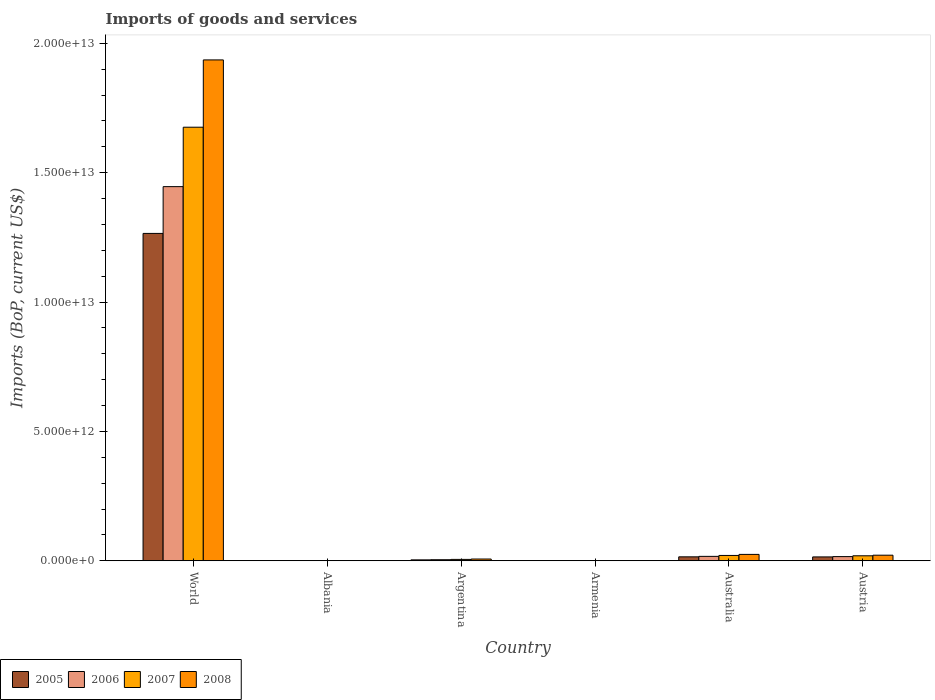How many different coloured bars are there?
Your answer should be very brief. 4. Are the number of bars on each tick of the X-axis equal?
Keep it short and to the point. Yes. How many bars are there on the 6th tick from the left?
Offer a very short reply. 4. What is the label of the 2nd group of bars from the left?
Keep it short and to the point. Albania. In how many cases, is the number of bars for a given country not equal to the number of legend labels?
Provide a short and direct response. 0. What is the amount spent on imports in 2007 in Austria?
Make the answer very short. 1.93e+11. Across all countries, what is the maximum amount spent on imports in 2008?
Make the answer very short. 1.94e+13. Across all countries, what is the minimum amount spent on imports in 2007?
Give a very brief answer. 3.88e+09. In which country was the amount spent on imports in 2006 maximum?
Your answer should be compact. World. In which country was the amount spent on imports in 2008 minimum?
Provide a succinct answer. Armenia. What is the total amount spent on imports in 2007 in the graph?
Offer a terse response. 1.72e+13. What is the difference between the amount spent on imports in 2007 in Austria and that in World?
Give a very brief answer. -1.66e+13. What is the difference between the amount spent on imports in 2008 in World and the amount spent on imports in 2006 in Argentina?
Ensure brevity in your answer.  1.93e+13. What is the average amount spent on imports in 2008 per country?
Offer a terse response. 3.32e+12. What is the difference between the amount spent on imports of/in 2005 and amount spent on imports of/in 2007 in World?
Your answer should be very brief. -4.10e+12. What is the ratio of the amount spent on imports in 2007 in Albania to that in Austria?
Make the answer very short. 0.03. Is the amount spent on imports in 2005 in Albania less than that in Armenia?
Make the answer very short. No. Is the difference between the amount spent on imports in 2005 in Albania and World greater than the difference between the amount spent on imports in 2007 in Albania and World?
Provide a short and direct response. Yes. What is the difference between the highest and the second highest amount spent on imports in 2007?
Your answer should be very brief. 1.66e+13. What is the difference between the highest and the lowest amount spent on imports in 2007?
Your answer should be compact. 1.68e+13. Is the sum of the amount spent on imports in 2005 in Albania and Austria greater than the maximum amount spent on imports in 2008 across all countries?
Your answer should be compact. No. Is it the case that in every country, the sum of the amount spent on imports in 2008 and amount spent on imports in 2006 is greater than the sum of amount spent on imports in 2007 and amount spent on imports in 2005?
Provide a succinct answer. No. What does the 3rd bar from the left in Australia represents?
Provide a short and direct response. 2007. Are all the bars in the graph horizontal?
Offer a very short reply. No. What is the difference between two consecutive major ticks on the Y-axis?
Your answer should be very brief. 5.00e+12. Are the values on the major ticks of Y-axis written in scientific E-notation?
Offer a terse response. Yes. Does the graph contain any zero values?
Keep it short and to the point. No. How are the legend labels stacked?
Provide a short and direct response. Horizontal. What is the title of the graph?
Ensure brevity in your answer.  Imports of goods and services. Does "2015" appear as one of the legend labels in the graph?
Your answer should be very brief. No. What is the label or title of the Y-axis?
Provide a short and direct response. Imports (BoP, current US$). What is the Imports (BoP, current US$) of 2005 in World?
Your answer should be very brief. 1.27e+13. What is the Imports (BoP, current US$) of 2006 in World?
Provide a succinct answer. 1.45e+13. What is the Imports (BoP, current US$) in 2007 in World?
Make the answer very short. 1.68e+13. What is the Imports (BoP, current US$) of 2008 in World?
Your answer should be very brief. 1.94e+13. What is the Imports (BoP, current US$) in 2005 in Albania?
Offer a very short reply. 3.50e+09. What is the Imports (BoP, current US$) in 2006 in Albania?
Keep it short and to the point. 4.07e+09. What is the Imports (BoP, current US$) in 2007 in Albania?
Make the answer very short. 5.34e+09. What is the Imports (BoP, current US$) of 2008 in Albania?
Your answer should be compact. 6.73e+09. What is the Imports (BoP, current US$) of 2005 in Argentina?
Keep it short and to the point. 3.48e+1. What is the Imports (BoP, current US$) of 2006 in Argentina?
Keep it short and to the point. 4.10e+1. What is the Imports (BoP, current US$) in 2007 in Argentina?
Your response must be concise. 5.32e+1. What is the Imports (BoP, current US$) in 2008 in Argentina?
Make the answer very short. 6.79e+1. What is the Imports (BoP, current US$) in 2005 in Armenia?
Give a very brief answer. 2.24e+09. What is the Imports (BoP, current US$) of 2006 in Armenia?
Offer a very short reply. 2.68e+09. What is the Imports (BoP, current US$) of 2007 in Armenia?
Your answer should be very brief. 3.88e+09. What is the Imports (BoP, current US$) of 2008 in Armenia?
Make the answer very short. 5.07e+09. What is the Imports (BoP, current US$) in 2005 in Australia?
Your response must be concise. 1.52e+11. What is the Imports (BoP, current US$) in 2006 in Australia?
Provide a short and direct response. 1.70e+11. What is the Imports (BoP, current US$) in 2007 in Australia?
Make the answer very short. 2.06e+11. What is the Imports (BoP, current US$) of 2008 in Australia?
Ensure brevity in your answer.  2.46e+11. What is the Imports (BoP, current US$) in 2005 in Austria?
Ensure brevity in your answer.  1.49e+11. What is the Imports (BoP, current US$) in 2006 in Austria?
Your answer should be very brief. 1.61e+11. What is the Imports (BoP, current US$) in 2007 in Austria?
Make the answer very short. 1.93e+11. What is the Imports (BoP, current US$) of 2008 in Austria?
Your response must be concise. 2.16e+11. Across all countries, what is the maximum Imports (BoP, current US$) in 2005?
Provide a short and direct response. 1.27e+13. Across all countries, what is the maximum Imports (BoP, current US$) of 2006?
Provide a short and direct response. 1.45e+13. Across all countries, what is the maximum Imports (BoP, current US$) in 2007?
Your answer should be very brief. 1.68e+13. Across all countries, what is the maximum Imports (BoP, current US$) in 2008?
Make the answer very short. 1.94e+13. Across all countries, what is the minimum Imports (BoP, current US$) in 2005?
Keep it short and to the point. 2.24e+09. Across all countries, what is the minimum Imports (BoP, current US$) in 2006?
Provide a short and direct response. 2.68e+09. Across all countries, what is the minimum Imports (BoP, current US$) in 2007?
Make the answer very short. 3.88e+09. Across all countries, what is the minimum Imports (BoP, current US$) of 2008?
Offer a very short reply. 5.07e+09. What is the total Imports (BoP, current US$) in 2005 in the graph?
Offer a terse response. 1.30e+13. What is the total Imports (BoP, current US$) in 2006 in the graph?
Your response must be concise. 1.48e+13. What is the total Imports (BoP, current US$) in 2007 in the graph?
Offer a very short reply. 1.72e+13. What is the total Imports (BoP, current US$) of 2008 in the graph?
Make the answer very short. 1.99e+13. What is the difference between the Imports (BoP, current US$) in 2005 in World and that in Albania?
Ensure brevity in your answer.  1.26e+13. What is the difference between the Imports (BoP, current US$) of 2006 in World and that in Albania?
Your answer should be very brief. 1.45e+13. What is the difference between the Imports (BoP, current US$) of 2007 in World and that in Albania?
Your answer should be compact. 1.68e+13. What is the difference between the Imports (BoP, current US$) of 2008 in World and that in Albania?
Your answer should be very brief. 1.93e+13. What is the difference between the Imports (BoP, current US$) in 2005 in World and that in Argentina?
Your answer should be compact. 1.26e+13. What is the difference between the Imports (BoP, current US$) in 2006 in World and that in Argentina?
Your answer should be compact. 1.44e+13. What is the difference between the Imports (BoP, current US$) of 2007 in World and that in Argentina?
Offer a very short reply. 1.67e+13. What is the difference between the Imports (BoP, current US$) of 2008 in World and that in Argentina?
Give a very brief answer. 1.93e+13. What is the difference between the Imports (BoP, current US$) in 2005 in World and that in Armenia?
Offer a terse response. 1.26e+13. What is the difference between the Imports (BoP, current US$) in 2006 in World and that in Armenia?
Your answer should be compact. 1.45e+13. What is the difference between the Imports (BoP, current US$) in 2007 in World and that in Armenia?
Your answer should be very brief. 1.68e+13. What is the difference between the Imports (BoP, current US$) in 2008 in World and that in Armenia?
Give a very brief answer. 1.94e+13. What is the difference between the Imports (BoP, current US$) in 2005 in World and that in Australia?
Your response must be concise. 1.25e+13. What is the difference between the Imports (BoP, current US$) of 2006 in World and that in Australia?
Your response must be concise. 1.43e+13. What is the difference between the Imports (BoP, current US$) in 2007 in World and that in Australia?
Your answer should be very brief. 1.65e+13. What is the difference between the Imports (BoP, current US$) in 2008 in World and that in Australia?
Provide a succinct answer. 1.91e+13. What is the difference between the Imports (BoP, current US$) of 2005 in World and that in Austria?
Provide a succinct answer. 1.25e+13. What is the difference between the Imports (BoP, current US$) of 2006 in World and that in Austria?
Provide a succinct answer. 1.43e+13. What is the difference between the Imports (BoP, current US$) of 2007 in World and that in Austria?
Your response must be concise. 1.66e+13. What is the difference between the Imports (BoP, current US$) of 2008 in World and that in Austria?
Your answer should be very brief. 1.91e+13. What is the difference between the Imports (BoP, current US$) in 2005 in Albania and that in Argentina?
Give a very brief answer. -3.13e+1. What is the difference between the Imports (BoP, current US$) of 2006 in Albania and that in Argentina?
Provide a short and direct response. -3.69e+1. What is the difference between the Imports (BoP, current US$) in 2007 in Albania and that in Argentina?
Ensure brevity in your answer.  -4.79e+1. What is the difference between the Imports (BoP, current US$) in 2008 in Albania and that in Argentina?
Offer a very short reply. -6.11e+1. What is the difference between the Imports (BoP, current US$) in 2005 in Albania and that in Armenia?
Give a very brief answer. 1.26e+09. What is the difference between the Imports (BoP, current US$) of 2006 in Albania and that in Armenia?
Provide a succinct answer. 1.39e+09. What is the difference between the Imports (BoP, current US$) in 2007 in Albania and that in Armenia?
Ensure brevity in your answer.  1.47e+09. What is the difference between the Imports (BoP, current US$) in 2008 in Albania and that in Armenia?
Ensure brevity in your answer.  1.66e+09. What is the difference between the Imports (BoP, current US$) of 2005 in Albania and that in Australia?
Offer a very short reply. -1.49e+11. What is the difference between the Imports (BoP, current US$) in 2006 in Albania and that in Australia?
Offer a very short reply. -1.66e+11. What is the difference between the Imports (BoP, current US$) of 2007 in Albania and that in Australia?
Your response must be concise. -2.00e+11. What is the difference between the Imports (BoP, current US$) of 2008 in Albania and that in Australia?
Give a very brief answer. -2.40e+11. What is the difference between the Imports (BoP, current US$) in 2005 in Albania and that in Austria?
Your answer should be compact. -1.45e+11. What is the difference between the Imports (BoP, current US$) in 2006 in Albania and that in Austria?
Provide a succinct answer. -1.57e+11. What is the difference between the Imports (BoP, current US$) in 2007 in Albania and that in Austria?
Offer a very short reply. -1.87e+11. What is the difference between the Imports (BoP, current US$) in 2008 in Albania and that in Austria?
Make the answer very short. -2.09e+11. What is the difference between the Imports (BoP, current US$) in 2005 in Argentina and that in Armenia?
Your answer should be compact. 3.26e+1. What is the difference between the Imports (BoP, current US$) of 2006 in Argentina and that in Armenia?
Keep it short and to the point. 3.83e+1. What is the difference between the Imports (BoP, current US$) in 2007 in Argentina and that in Armenia?
Your answer should be very brief. 4.94e+1. What is the difference between the Imports (BoP, current US$) of 2008 in Argentina and that in Armenia?
Keep it short and to the point. 6.28e+1. What is the difference between the Imports (BoP, current US$) in 2005 in Argentina and that in Australia?
Provide a succinct answer. -1.17e+11. What is the difference between the Imports (BoP, current US$) of 2006 in Argentina and that in Australia?
Your answer should be very brief. -1.29e+11. What is the difference between the Imports (BoP, current US$) of 2007 in Argentina and that in Australia?
Give a very brief answer. -1.53e+11. What is the difference between the Imports (BoP, current US$) of 2008 in Argentina and that in Australia?
Make the answer very short. -1.79e+11. What is the difference between the Imports (BoP, current US$) in 2005 in Argentina and that in Austria?
Ensure brevity in your answer.  -1.14e+11. What is the difference between the Imports (BoP, current US$) in 2006 in Argentina and that in Austria?
Your answer should be very brief. -1.20e+11. What is the difference between the Imports (BoP, current US$) in 2007 in Argentina and that in Austria?
Ensure brevity in your answer.  -1.39e+11. What is the difference between the Imports (BoP, current US$) of 2008 in Argentina and that in Austria?
Give a very brief answer. -1.48e+11. What is the difference between the Imports (BoP, current US$) of 2005 in Armenia and that in Australia?
Your answer should be very brief. -1.50e+11. What is the difference between the Imports (BoP, current US$) in 2006 in Armenia and that in Australia?
Provide a succinct answer. -1.67e+11. What is the difference between the Imports (BoP, current US$) of 2007 in Armenia and that in Australia?
Your answer should be compact. -2.02e+11. What is the difference between the Imports (BoP, current US$) of 2008 in Armenia and that in Australia?
Give a very brief answer. -2.41e+11. What is the difference between the Imports (BoP, current US$) of 2005 in Armenia and that in Austria?
Keep it short and to the point. -1.47e+11. What is the difference between the Imports (BoP, current US$) of 2006 in Armenia and that in Austria?
Offer a very short reply. -1.59e+11. What is the difference between the Imports (BoP, current US$) in 2007 in Armenia and that in Austria?
Make the answer very short. -1.89e+11. What is the difference between the Imports (BoP, current US$) of 2008 in Armenia and that in Austria?
Keep it short and to the point. -2.10e+11. What is the difference between the Imports (BoP, current US$) in 2005 in Australia and that in Austria?
Your response must be concise. 3.31e+09. What is the difference between the Imports (BoP, current US$) of 2006 in Australia and that in Austria?
Offer a very short reply. 8.59e+09. What is the difference between the Imports (BoP, current US$) in 2007 in Australia and that in Austria?
Provide a succinct answer. 1.33e+1. What is the difference between the Imports (BoP, current US$) in 2008 in Australia and that in Austria?
Give a very brief answer. 3.09e+1. What is the difference between the Imports (BoP, current US$) of 2005 in World and the Imports (BoP, current US$) of 2006 in Albania?
Ensure brevity in your answer.  1.26e+13. What is the difference between the Imports (BoP, current US$) of 2005 in World and the Imports (BoP, current US$) of 2007 in Albania?
Provide a succinct answer. 1.26e+13. What is the difference between the Imports (BoP, current US$) in 2005 in World and the Imports (BoP, current US$) in 2008 in Albania?
Offer a very short reply. 1.26e+13. What is the difference between the Imports (BoP, current US$) of 2006 in World and the Imports (BoP, current US$) of 2007 in Albania?
Ensure brevity in your answer.  1.45e+13. What is the difference between the Imports (BoP, current US$) in 2006 in World and the Imports (BoP, current US$) in 2008 in Albania?
Keep it short and to the point. 1.45e+13. What is the difference between the Imports (BoP, current US$) in 2007 in World and the Imports (BoP, current US$) in 2008 in Albania?
Your answer should be very brief. 1.67e+13. What is the difference between the Imports (BoP, current US$) of 2005 in World and the Imports (BoP, current US$) of 2006 in Argentina?
Keep it short and to the point. 1.26e+13. What is the difference between the Imports (BoP, current US$) of 2005 in World and the Imports (BoP, current US$) of 2007 in Argentina?
Give a very brief answer. 1.26e+13. What is the difference between the Imports (BoP, current US$) in 2005 in World and the Imports (BoP, current US$) in 2008 in Argentina?
Ensure brevity in your answer.  1.26e+13. What is the difference between the Imports (BoP, current US$) in 2006 in World and the Imports (BoP, current US$) in 2007 in Argentina?
Your answer should be compact. 1.44e+13. What is the difference between the Imports (BoP, current US$) of 2006 in World and the Imports (BoP, current US$) of 2008 in Argentina?
Your answer should be compact. 1.44e+13. What is the difference between the Imports (BoP, current US$) of 2007 in World and the Imports (BoP, current US$) of 2008 in Argentina?
Give a very brief answer. 1.67e+13. What is the difference between the Imports (BoP, current US$) in 2005 in World and the Imports (BoP, current US$) in 2006 in Armenia?
Provide a short and direct response. 1.26e+13. What is the difference between the Imports (BoP, current US$) in 2005 in World and the Imports (BoP, current US$) in 2007 in Armenia?
Offer a terse response. 1.26e+13. What is the difference between the Imports (BoP, current US$) of 2005 in World and the Imports (BoP, current US$) of 2008 in Armenia?
Your answer should be compact. 1.26e+13. What is the difference between the Imports (BoP, current US$) of 2006 in World and the Imports (BoP, current US$) of 2007 in Armenia?
Your response must be concise. 1.45e+13. What is the difference between the Imports (BoP, current US$) of 2006 in World and the Imports (BoP, current US$) of 2008 in Armenia?
Give a very brief answer. 1.45e+13. What is the difference between the Imports (BoP, current US$) in 2007 in World and the Imports (BoP, current US$) in 2008 in Armenia?
Provide a succinct answer. 1.68e+13. What is the difference between the Imports (BoP, current US$) of 2005 in World and the Imports (BoP, current US$) of 2006 in Australia?
Your answer should be compact. 1.25e+13. What is the difference between the Imports (BoP, current US$) of 2005 in World and the Imports (BoP, current US$) of 2007 in Australia?
Give a very brief answer. 1.24e+13. What is the difference between the Imports (BoP, current US$) in 2005 in World and the Imports (BoP, current US$) in 2008 in Australia?
Your answer should be compact. 1.24e+13. What is the difference between the Imports (BoP, current US$) in 2006 in World and the Imports (BoP, current US$) in 2007 in Australia?
Your answer should be very brief. 1.43e+13. What is the difference between the Imports (BoP, current US$) of 2006 in World and the Imports (BoP, current US$) of 2008 in Australia?
Your answer should be compact. 1.42e+13. What is the difference between the Imports (BoP, current US$) in 2007 in World and the Imports (BoP, current US$) in 2008 in Australia?
Your answer should be very brief. 1.65e+13. What is the difference between the Imports (BoP, current US$) in 2005 in World and the Imports (BoP, current US$) in 2006 in Austria?
Make the answer very short. 1.25e+13. What is the difference between the Imports (BoP, current US$) of 2005 in World and the Imports (BoP, current US$) of 2007 in Austria?
Give a very brief answer. 1.25e+13. What is the difference between the Imports (BoP, current US$) in 2005 in World and the Imports (BoP, current US$) in 2008 in Austria?
Give a very brief answer. 1.24e+13. What is the difference between the Imports (BoP, current US$) of 2006 in World and the Imports (BoP, current US$) of 2007 in Austria?
Keep it short and to the point. 1.43e+13. What is the difference between the Imports (BoP, current US$) in 2006 in World and the Imports (BoP, current US$) in 2008 in Austria?
Your answer should be compact. 1.42e+13. What is the difference between the Imports (BoP, current US$) of 2007 in World and the Imports (BoP, current US$) of 2008 in Austria?
Your answer should be compact. 1.65e+13. What is the difference between the Imports (BoP, current US$) of 2005 in Albania and the Imports (BoP, current US$) of 2006 in Argentina?
Provide a succinct answer. -3.75e+1. What is the difference between the Imports (BoP, current US$) in 2005 in Albania and the Imports (BoP, current US$) in 2007 in Argentina?
Make the answer very short. -4.97e+1. What is the difference between the Imports (BoP, current US$) in 2005 in Albania and the Imports (BoP, current US$) in 2008 in Argentina?
Ensure brevity in your answer.  -6.43e+1. What is the difference between the Imports (BoP, current US$) of 2006 in Albania and the Imports (BoP, current US$) of 2007 in Argentina?
Make the answer very short. -4.92e+1. What is the difference between the Imports (BoP, current US$) in 2006 in Albania and the Imports (BoP, current US$) in 2008 in Argentina?
Provide a short and direct response. -6.38e+1. What is the difference between the Imports (BoP, current US$) in 2007 in Albania and the Imports (BoP, current US$) in 2008 in Argentina?
Keep it short and to the point. -6.25e+1. What is the difference between the Imports (BoP, current US$) of 2005 in Albania and the Imports (BoP, current US$) of 2006 in Armenia?
Your response must be concise. 8.18e+08. What is the difference between the Imports (BoP, current US$) of 2005 in Albania and the Imports (BoP, current US$) of 2007 in Armenia?
Keep it short and to the point. -3.75e+08. What is the difference between the Imports (BoP, current US$) of 2005 in Albania and the Imports (BoP, current US$) of 2008 in Armenia?
Ensure brevity in your answer.  -1.57e+09. What is the difference between the Imports (BoP, current US$) of 2006 in Albania and the Imports (BoP, current US$) of 2007 in Armenia?
Provide a short and direct response. 1.98e+08. What is the difference between the Imports (BoP, current US$) of 2006 in Albania and the Imports (BoP, current US$) of 2008 in Armenia?
Offer a very short reply. -9.98e+08. What is the difference between the Imports (BoP, current US$) of 2007 in Albania and the Imports (BoP, current US$) of 2008 in Armenia?
Your answer should be compact. 2.73e+08. What is the difference between the Imports (BoP, current US$) in 2005 in Albania and the Imports (BoP, current US$) in 2006 in Australia?
Offer a terse response. -1.67e+11. What is the difference between the Imports (BoP, current US$) in 2005 in Albania and the Imports (BoP, current US$) in 2007 in Australia?
Make the answer very short. -2.02e+11. What is the difference between the Imports (BoP, current US$) of 2005 in Albania and the Imports (BoP, current US$) of 2008 in Australia?
Provide a succinct answer. -2.43e+11. What is the difference between the Imports (BoP, current US$) in 2006 in Albania and the Imports (BoP, current US$) in 2007 in Australia?
Your answer should be compact. -2.02e+11. What is the difference between the Imports (BoP, current US$) in 2006 in Albania and the Imports (BoP, current US$) in 2008 in Australia?
Your response must be concise. -2.42e+11. What is the difference between the Imports (BoP, current US$) in 2007 in Albania and the Imports (BoP, current US$) in 2008 in Australia?
Ensure brevity in your answer.  -2.41e+11. What is the difference between the Imports (BoP, current US$) of 2005 in Albania and the Imports (BoP, current US$) of 2006 in Austria?
Give a very brief answer. -1.58e+11. What is the difference between the Imports (BoP, current US$) in 2005 in Albania and the Imports (BoP, current US$) in 2007 in Austria?
Ensure brevity in your answer.  -1.89e+11. What is the difference between the Imports (BoP, current US$) in 2005 in Albania and the Imports (BoP, current US$) in 2008 in Austria?
Your answer should be very brief. -2.12e+11. What is the difference between the Imports (BoP, current US$) in 2006 in Albania and the Imports (BoP, current US$) in 2007 in Austria?
Provide a succinct answer. -1.88e+11. What is the difference between the Imports (BoP, current US$) of 2006 in Albania and the Imports (BoP, current US$) of 2008 in Austria?
Ensure brevity in your answer.  -2.11e+11. What is the difference between the Imports (BoP, current US$) in 2007 in Albania and the Imports (BoP, current US$) in 2008 in Austria?
Your answer should be very brief. -2.10e+11. What is the difference between the Imports (BoP, current US$) of 2005 in Argentina and the Imports (BoP, current US$) of 2006 in Armenia?
Keep it short and to the point. 3.21e+1. What is the difference between the Imports (BoP, current US$) in 2005 in Argentina and the Imports (BoP, current US$) in 2007 in Armenia?
Make the answer very short. 3.09e+1. What is the difference between the Imports (BoP, current US$) in 2005 in Argentina and the Imports (BoP, current US$) in 2008 in Armenia?
Provide a succinct answer. 2.97e+1. What is the difference between the Imports (BoP, current US$) of 2006 in Argentina and the Imports (BoP, current US$) of 2007 in Armenia?
Provide a succinct answer. 3.71e+1. What is the difference between the Imports (BoP, current US$) in 2006 in Argentina and the Imports (BoP, current US$) in 2008 in Armenia?
Give a very brief answer. 3.59e+1. What is the difference between the Imports (BoP, current US$) in 2007 in Argentina and the Imports (BoP, current US$) in 2008 in Armenia?
Your answer should be compact. 4.82e+1. What is the difference between the Imports (BoP, current US$) in 2005 in Argentina and the Imports (BoP, current US$) in 2006 in Australia?
Provide a short and direct response. -1.35e+11. What is the difference between the Imports (BoP, current US$) of 2005 in Argentina and the Imports (BoP, current US$) of 2007 in Australia?
Keep it short and to the point. -1.71e+11. What is the difference between the Imports (BoP, current US$) of 2005 in Argentina and the Imports (BoP, current US$) of 2008 in Australia?
Offer a terse response. -2.12e+11. What is the difference between the Imports (BoP, current US$) of 2006 in Argentina and the Imports (BoP, current US$) of 2007 in Australia?
Make the answer very short. -1.65e+11. What is the difference between the Imports (BoP, current US$) of 2006 in Argentina and the Imports (BoP, current US$) of 2008 in Australia?
Provide a succinct answer. -2.05e+11. What is the difference between the Imports (BoP, current US$) of 2007 in Argentina and the Imports (BoP, current US$) of 2008 in Australia?
Give a very brief answer. -1.93e+11. What is the difference between the Imports (BoP, current US$) of 2005 in Argentina and the Imports (BoP, current US$) of 2006 in Austria?
Offer a terse response. -1.27e+11. What is the difference between the Imports (BoP, current US$) of 2005 in Argentina and the Imports (BoP, current US$) of 2007 in Austria?
Your answer should be very brief. -1.58e+11. What is the difference between the Imports (BoP, current US$) in 2005 in Argentina and the Imports (BoP, current US$) in 2008 in Austria?
Offer a terse response. -1.81e+11. What is the difference between the Imports (BoP, current US$) in 2006 in Argentina and the Imports (BoP, current US$) in 2007 in Austria?
Keep it short and to the point. -1.52e+11. What is the difference between the Imports (BoP, current US$) of 2006 in Argentina and the Imports (BoP, current US$) of 2008 in Austria?
Provide a short and direct response. -1.75e+11. What is the difference between the Imports (BoP, current US$) of 2007 in Argentina and the Imports (BoP, current US$) of 2008 in Austria?
Provide a succinct answer. -1.62e+11. What is the difference between the Imports (BoP, current US$) of 2005 in Armenia and the Imports (BoP, current US$) of 2006 in Australia?
Provide a short and direct response. -1.68e+11. What is the difference between the Imports (BoP, current US$) in 2005 in Armenia and the Imports (BoP, current US$) in 2007 in Australia?
Ensure brevity in your answer.  -2.04e+11. What is the difference between the Imports (BoP, current US$) in 2005 in Armenia and the Imports (BoP, current US$) in 2008 in Australia?
Provide a succinct answer. -2.44e+11. What is the difference between the Imports (BoP, current US$) in 2006 in Armenia and the Imports (BoP, current US$) in 2007 in Australia?
Your response must be concise. -2.03e+11. What is the difference between the Imports (BoP, current US$) of 2006 in Armenia and the Imports (BoP, current US$) of 2008 in Australia?
Give a very brief answer. -2.44e+11. What is the difference between the Imports (BoP, current US$) in 2007 in Armenia and the Imports (BoP, current US$) in 2008 in Australia?
Offer a very short reply. -2.43e+11. What is the difference between the Imports (BoP, current US$) in 2005 in Armenia and the Imports (BoP, current US$) in 2006 in Austria?
Make the answer very short. -1.59e+11. What is the difference between the Imports (BoP, current US$) of 2005 in Armenia and the Imports (BoP, current US$) of 2007 in Austria?
Ensure brevity in your answer.  -1.90e+11. What is the difference between the Imports (BoP, current US$) of 2005 in Armenia and the Imports (BoP, current US$) of 2008 in Austria?
Offer a very short reply. -2.13e+11. What is the difference between the Imports (BoP, current US$) of 2006 in Armenia and the Imports (BoP, current US$) of 2007 in Austria?
Your answer should be compact. -1.90e+11. What is the difference between the Imports (BoP, current US$) in 2006 in Armenia and the Imports (BoP, current US$) in 2008 in Austria?
Ensure brevity in your answer.  -2.13e+11. What is the difference between the Imports (BoP, current US$) of 2007 in Armenia and the Imports (BoP, current US$) of 2008 in Austria?
Provide a short and direct response. -2.12e+11. What is the difference between the Imports (BoP, current US$) of 2005 in Australia and the Imports (BoP, current US$) of 2006 in Austria?
Your response must be concise. -9.18e+09. What is the difference between the Imports (BoP, current US$) in 2005 in Australia and the Imports (BoP, current US$) in 2007 in Austria?
Keep it short and to the point. -4.03e+1. What is the difference between the Imports (BoP, current US$) in 2005 in Australia and the Imports (BoP, current US$) in 2008 in Austria?
Your answer should be very brief. -6.32e+1. What is the difference between the Imports (BoP, current US$) in 2006 in Australia and the Imports (BoP, current US$) in 2007 in Austria?
Provide a succinct answer. -2.25e+1. What is the difference between the Imports (BoP, current US$) of 2006 in Australia and the Imports (BoP, current US$) of 2008 in Austria?
Offer a very short reply. -4.55e+1. What is the difference between the Imports (BoP, current US$) of 2007 in Australia and the Imports (BoP, current US$) of 2008 in Austria?
Your answer should be very brief. -9.68e+09. What is the average Imports (BoP, current US$) of 2005 per country?
Your answer should be very brief. 2.17e+12. What is the average Imports (BoP, current US$) in 2006 per country?
Offer a very short reply. 2.47e+12. What is the average Imports (BoP, current US$) of 2007 per country?
Your answer should be compact. 2.87e+12. What is the average Imports (BoP, current US$) in 2008 per country?
Your answer should be very brief. 3.32e+12. What is the difference between the Imports (BoP, current US$) in 2005 and Imports (BoP, current US$) in 2006 in World?
Make the answer very short. -1.81e+12. What is the difference between the Imports (BoP, current US$) of 2005 and Imports (BoP, current US$) of 2007 in World?
Give a very brief answer. -4.10e+12. What is the difference between the Imports (BoP, current US$) in 2005 and Imports (BoP, current US$) in 2008 in World?
Offer a very short reply. -6.71e+12. What is the difference between the Imports (BoP, current US$) of 2006 and Imports (BoP, current US$) of 2007 in World?
Ensure brevity in your answer.  -2.30e+12. What is the difference between the Imports (BoP, current US$) of 2006 and Imports (BoP, current US$) of 2008 in World?
Keep it short and to the point. -4.90e+12. What is the difference between the Imports (BoP, current US$) of 2007 and Imports (BoP, current US$) of 2008 in World?
Make the answer very short. -2.60e+12. What is the difference between the Imports (BoP, current US$) in 2005 and Imports (BoP, current US$) in 2006 in Albania?
Provide a short and direct response. -5.73e+08. What is the difference between the Imports (BoP, current US$) of 2005 and Imports (BoP, current US$) of 2007 in Albania?
Ensure brevity in your answer.  -1.84e+09. What is the difference between the Imports (BoP, current US$) of 2005 and Imports (BoP, current US$) of 2008 in Albania?
Your answer should be compact. -3.23e+09. What is the difference between the Imports (BoP, current US$) in 2006 and Imports (BoP, current US$) in 2007 in Albania?
Your answer should be compact. -1.27e+09. What is the difference between the Imports (BoP, current US$) in 2006 and Imports (BoP, current US$) in 2008 in Albania?
Your answer should be compact. -2.66e+09. What is the difference between the Imports (BoP, current US$) of 2007 and Imports (BoP, current US$) of 2008 in Albania?
Offer a very short reply. -1.39e+09. What is the difference between the Imports (BoP, current US$) of 2005 and Imports (BoP, current US$) of 2006 in Argentina?
Give a very brief answer. -6.18e+09. What is the difference between the Imports (BoP, current US$) in 2005 and Imports (BoP, current US$) in 2007 in Argentina?
Provide a succinct answer. -1.84e+1. What is the difference between the Imports (BoP, current US$) in 2005 and Imports (BoP, current US$) in 2008 in Argentina?
Provide a short and direct response. -3.31e+1. What is the difference between the Imports (BoP, current US$) of 2006 and Imports (BoP, current US$) of 2007 in Argentina?
Provide a succinct answer. -1.23e+1. What is the difference between the Imports (BoP, current US$) of 2006 and Imports (BoP, current US$) of 2008 in Argentina?
Provide a short and direct response. -2.69e+1. What is the difference between the Imports (BoP, current US$) in 2007 and Imports (BoP, current US$) in 2008 in Argentina?
Offer a very short reply. -1.46e+1. What is the difference between the Imports (BoP, current US$) in 2005 and Imports (BoP, current US$) in 2006 in Armenia?
Your answer should be very brief. -4.41e+08. What is the difference between the Imports (BoP, current US$) of 2005 and Imports (BoP, current US$) of 2007 in Armenia?
Your answer should be compact. -1.63e+09. What is the difference between the Imports (BoP, current US$) of 2005 and Imports (BoP, current US$) of 2008 in Armenia?
Your answer should be very brief. -2.83e+09. What is the difference between the Imports (BoP, current US$) of 2006 and Imports (BoP, current US$) of 2007 in Armenia?
Make the answer very short. -1.19e+09. What is the difference between the Imports (BoP, current US$) in 2006 and Imports (BoP, current US$) in 2008 in Armenia?
Offer a very short reply. -2.39e+09. What is the difference between the Imports (BoP, current US$) in 2007 and Imports (BoP, current US$) in 2008 in Armenia?
Your answer should be very brief. -1.20e+09. What is the difference between the Imports (BoP, current US$) of 2005 and Imports (BoP, current US$) of 2006 in Australia?
Provide a short and direct response. -1.78e+1. What is the difference between the Imports (BoP, current US$) of 2005 and Imports (BoP, current US$) of 2007 in Australia?
Make the answer very short. -5.36e+1. What is the difference between the Imports (BoP, current US$) of 2005 and Imports (BoP, current US$) of 2008 in Australia?
Offer a terse response. -9.42e+1. What is the difference between the Imports (BoP, current US$) in 2006 and Imports (BoP, current US$) in 2007 in Australia?
Keep it short and to the point. -3.58e+1. What is the difference between the Imports (BoP, current US$) of 2006 and Imports (BoP, current US$) of 2008 in Australia?
Provide a succinct answer. -7.64e+1. What is the difference between the Imports (BoP, current US$) in 2007 and Imports (BoP, current US$) in 2008 in Australia?
Your answer should be compact. -4.06e+1. What is the difference between the Imports (BoP, current US$) in 2005 and Imports (BoP, current US$) in 2006 in Austria?
Provide a short and direct response. -1.25e+1. What is the difference between the Imports (BoP, current US$) of 2005 and Imports (BoP, current US$) of 2007 in Austria?
Provide a short and direct response. -4.36e+1. What is the difference between the Imports (BoP, current US$) in 2005 and Imports (BoP, current US$) in 2008 in Austria?
Offer a terse response. -6.66e+1. What is the difference between the Imports (BoP, current US$) of 2006 and Imports (BoP, current US$) of 2007 in Austria?
Give a very brief answer. -3.11e+1. What is the difference between the Imports (BoP, current US$) of 2006 and Imports (BoP, current US$) of 2008 in Austria?
Make the answer very short. -5.41e+1. What is the difference between the Imports (BoP, current US$) of 2007 and Imports (BoP, current US$) of 2008 in Austria?
Make the answer very short. -2.30e+1. What is the ratio of the Imports (BoP, current US$) in 2005 in World to that in Albania?
Keep it short and to the point. 3614.24. What is the ratio of the Imports (BoP, current US$) of 2006 in World to that in Albania?
Give a very brief answer. 3549.9. What is the ratio of the Imports (BoP, current US$) in 2007 in World to that in Albania?
Give a very brief answer. 3135.35. What is the ratio of the Imports (BoP, current US$) of 2008 in World to that in Albania?
Provide a succinct answer. 2875.75. What is the ratio of the Imports (BoP, current US$) of 2005 in World to that in Argentina?
Your answer should be compact. 363.57. What is the ratio of the Imports (BoP, current US$) of 2006 in World to that in Argentina?
Give a very brief answer. 352.89. What is the ratio of the Imports (BoP, current US$) of 2007 in World to that in Argentina?
Your answer should be very brief. 314.8. What is the ratio of the Imports (BoP, current US$) in 2008 in World to that in Argentina?
Give a very brief answer. 285.28. What is the ratio of the Imports (BoP, current US$) in 2005 in World to that in Armenia?
Keep it short and to the point. 5644.18. What is the ratio of the Imports (BoP, current US$) in 2006 in World to that in Armenia?
Provide a succinct answer. 5391.26. What is the ratio of the Imports (BoP, current US$) of 2007 in World to that in Armenia?
Your response must be concise. 4323.73. What is the ratio of the Imports (BoP, current US$) in 2008 in World to that in Armenia?
Keep it short and to the point. 3816.97. What is the ratio of the Imports (BoP, current US$) in 2005 in World to that in Australia?
Make the answer very short. 83.09. What is the ratio of the Imports (BoP, current US$) of 2006 in World to that in Australia?
Provide a short and direct response. 85.04. What is the ratio of the Imports (BoP, current US$) in 2007 in World to that in Australia?
Offer a terse response. 81.41. What is the ratio of the Imports (BoP, current US$) in 2008 in World to that in Australia?
Keep it short and to the point. 78.55. What is the ratio of the Imports (BoP, current US$) in 2005 in World to that in Austria?
Your answer should be very brief. 84.94. What is the ratio of the Imports (BoP, current US$) of 2006 in World to that in Austria?
Keep it short and to the point. 89.57. What is the ratio of the Imports (BoP, current US$) in 2007 in World to that in Austria?
Ensure brevity in your answer.  87.02. What is the ratio of the Imports (BoP, current US$) in 2008 in World to that in Austria?
Give a very brief answer. 89.82. What is the ratio of the Imports (BoP, current US$) of 2005 in Albania to that in Argentina?
Offer a terse response. 0.1. What is the ratio of the Imports (BoP, current US$) in 2006 in Albania to that in Argentina?
Offer a very short reply. 0.1. What is the ratio of the Imports (BoP, current US$) in 2007 in Albania to that in Argentina?
Your answer should be very brief. 0.1. What is the ratio of the Imports (BoP, current US$) in 2008 in Albania to that in Argentina?
Provide a succinct answer. 0.1. What is the ratio of the Imports (BoP, current US$) in 2005 in Albania to that in Armenia?
Give a very brief answer. 1.56. What is the ratio of the Imports (BoP, current US$) of 2006 in Albania to that in Armenia?
Provide a succinct answer. 1.52. What is the ratio of the Imports (BoP, current US$) in 2007 in Albania to that in Armenia?
Offer a very short reply. 1.38. What is the ratio of the Imports (BoP, current US$) of 2008 in Albania to that in Armenia?
Offer a very short reply. 1.33. What is the ratio of the Imports (BoP, current US$) of 2005 in Albania to that in Australia?
Your answer should be compact. 0.02. What is the ratio of the Imports (BoP, current US$) in 2006 in Albania to that in Australia?
Give a very brief answer. 0.02. What is the ratio of the Imports (BoP, current US$) in 2007 in Albania to that in Australia?
Provide a short and direct response. 0.03. What is the ratio of the Imports (BoP, current US$) of 2008 in Albania to that in Australia?
Provide a succinct answer. 0.03. What is the ratio of the Imports (BoP, current US$) in 2005 in Albania to that in Austria?
Make the answer very short. 0.02. What is the ratio of the Imports (BoP, current US$) in 2006 in Albania to that in Austria?
Your answer should be compact. 0.03. What is the ratio of the Imports (BoP, current US$) in 2007 in Albania to that in Austria?
Offer a very short reply. 0.03. What is the ratio of the Imports (BoP, current US$) in 2008 in Albania to that in Austria?
Make the answer very short. 0.03. What is the ratio of the Imports (BoP, current US$) in 2005 in Argentina to that in Armenia?
Your response must be concise. 15.52. What is the ratio of the Imports (BoP, current US$) in 2006 in Argentina to that in Armenia?
Offer a very short reply. 15.28. What is the ratio of the Imports (BoP, current US$) in 2007 in Argentina to that in Armenia?
Give a very brief answer. 13.73. What is the ratio of the Imports (BoP, current US$) of 2008 in Argentina to that in Armenia?
Your response must be concise. 13.38. What is the ratio of the Imports (BoP, current US$) of 2005 in Argentina to that in Australia?
Offer a very short reply. 0.23. What is the ratio of the Imports (BoP, current US$) in 2006 in Argentina to that in Australia?
Provide a short and direct response. 0.24. What is the ratio of the Imports (BoP, current US$) of 2007 in Argentina to that in Australia?
Offer a very short reply. 0.26. What is the ratio of the Imports (BoP, current US$) of 2008 in Argentina to that in Australia?
Your response must be concise. 0.28. What is the ratio of the Imports (BoP, current US$) in 2005 in Argentina to that in Austria?
Your response must be concise. 0.23. What is the ratio of the Imports (BoP, current US$) of 2006 in Argentina to that in Austria?
Provide a succinct answer. 0.25. What is the ratio of the Imports (BoP, current US$) in 2007 in Argentina to that in Austria?
Offer a terse response. 0.28. What is the ratio of the Imports (BoP, current US$) in 2008 in Argentina to that in Austria?
Keep it short and to the point. 0.31. What is the ratio of the Imports (BoP, current US$) in 2005 in Armenia to that in Australia?
Ensure brevity in your answer.  0.01. What is the ratio of the Imports (BoP, current US$) in 2006 in Armenia to that in Australia?
Offer a very short reply. 0.02. What is the ratio of the Imports (BoP, current US$) of 2007 in Armenia to that in Australia?
Your response must be concise. 0.02. What is the ratio of the Imports (BoP, current US$) of 2008 in Armenia to that in Australia?
Offer a terse response. 0.02. What is the ratio of the Imports (BoP, current US$) in 2005 in Armenia to that in Austria?
Offer a very short reply. 0.01. What is the ratio of the Imports (BoP, current US$) in 2006 in Armenia to that in Austria?
Your response must be concise. 0.02. What is the ratio of the Imports (BoP, current US$) of 2007 in Armenia to that in Austria?
Your answer should be compact. 0.02. What is the ratio of the Imports (BoP, current US$) of 2008 in Armenia to that in Austria?
Offer a very short reply. 0.02. What is the ratio of the Imports (BoP, current US$) of 2005 in Australia to that in Austria?
Provide a short and direct response. 1.02. What is the ratio of the Imports (BoP, current US$) in 2006 in Australia to that in Austria?
Offer a very short reply. 1.05. What is the ratio of the Imports (BoP, current US$) of 2007 in Australia to that in Austria?
Offer a very short reply. 1.07. What is the ratio of the Imports (BoP, current US$) in 2008 in Australia to that in Austria?
Give a very brief answer. 1.14. What is the difference between the highest and the second highest Imports (BoP, current US$) of 2005?
Give a very brief answer. 1.25e+13. What is the difference between the highest and the second highest Imports (BoP, current US$) of 2006?
Keep it short and to the point. 1.43e+13. What is the difference between the highest and the second highest Imports (BoP, current US$) of 2007?
Your answer should be very brief. 1.65e+13. What is the difference between the highest and the second highest Imports (BoP, current US$) in 2008?
Your answer should be compact. 1.91e+13. What is the difference between the highest and the lowest Imports (BoP, current US$) in 2005?
Offer a terse response. 1.26e+13. What is the difference between the highest and the lowest Imports (BoP, current US$) in 2006?
Offer a terse response. 1.45e+13. What is the difference between the highest and the lowest Imports (BoP, current US$) in 2007?
Your answer should be very brief. 1.68e+13. What is the difference between the highest and the lowest Imports (BoP, current US$) of 2008?
Make the answer very short. 1.94e+13. 